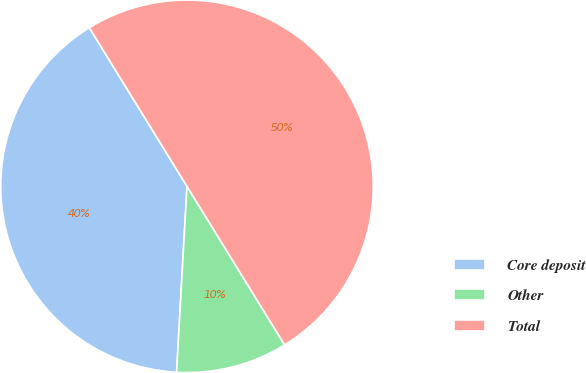<chart> <loc_0><loc_0><loc_500><loc_500><pie_chart><fcel>Core deposit<fcel>Other<fcel>Total<nl><fcel>40.33%<fcel>9.67%<fcel>50.0%<nl></chart> 